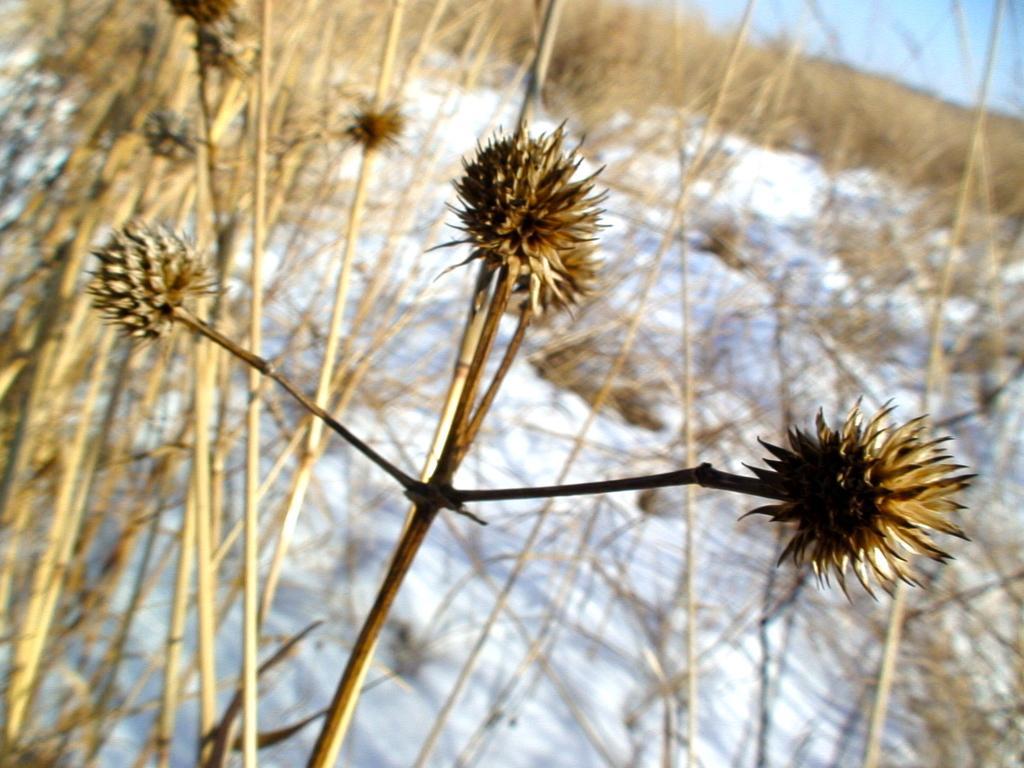Can you describe this image briefly? In this picture I can see there are plants and there is the snow, in the top right hand side corner there is the sky. 